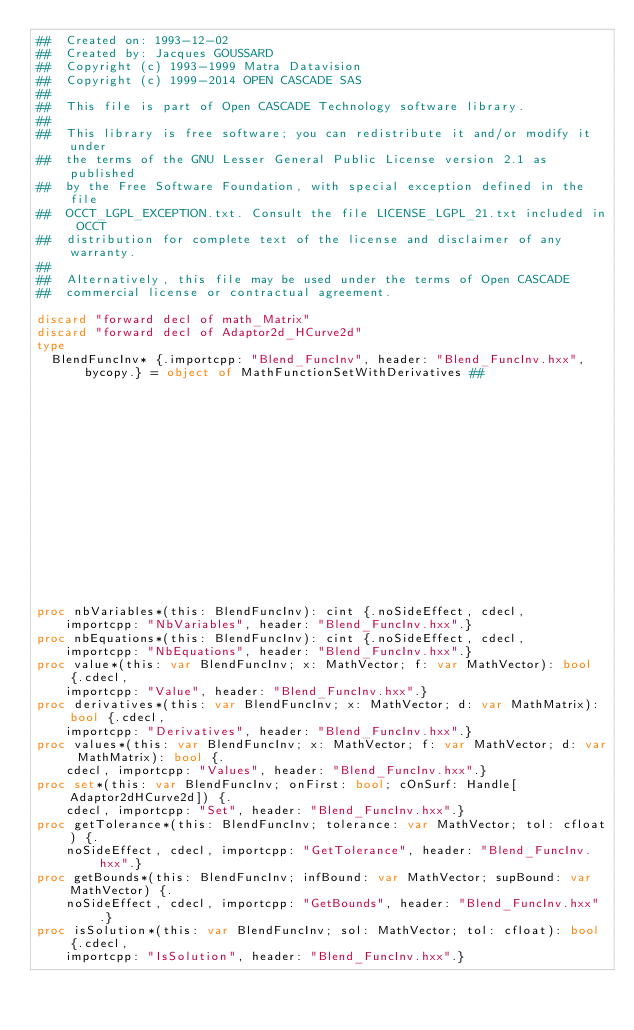Convert code to text. <code><loc_0><loc_0><loc_500><loc_500><_Nim_>##  Created on: 1993-12-02
##  Created by: Jacques GOUSSARD
##  Copyright (c) 1993-1999 Matra Datavision
##  Copyright (c) 1999-2014 OPEN CASCADE SAS
##
##  This file is part of Open CASCADE Technology software library.
##
##  This library is free software; you can redistribute it and/or modify it under
##  the terms of the GNU Lesser General Public License version 2.1 as published
##  by the Free Software Foundation, with special exception defined in the file
##  OCCT_LGPL_EXCEPTION.txt. Consult the file LICENSE_LGPL_21.txt included in OCCT
##  distribution for complete text of the license and disclaimer of any warranty.
##
##  Alternatively, this file may be used under the terms of Open CASCADE
##  commercial license or contractual agreement.

discard "forward decl of math_Matrix"
discard "forward decl of Adaptor2d_HCurve2d"
type
  BlendFuncInv* {.importcpp: "Blend_FuncInv", header: "Blend_FuncInv.hxx", bycopy.} = object of MathFunctionSetWithDerivatives ##
                                                                                                                     ## !
                                                                                                                     ## Returns
                                                                                                                     ## 4.


proc nbVariables*(this: BlendFuncInv): cint {.noSideEffect, cdecl,
    importcpp: "NbVariables", header: "Blend_FuncInv.hxx".}
proc nbEquations*(this: BlendFuncInv): cint {.noSideEffect, cdecl,
    importcpp: "NbEquations", header: "Blend_FuncInv.hxx".}
proc value*(this: var BlendFuncInv; x: MathVector; f: var MathVector): bool {.cdecl,
    importcpp: "Value", header: "Blend_FuncInv.hxx".}
proc derivatives*(this: var BlendFuncInv; x: MathVector; d: var MathMatrix): bool {.cdecl,
    importcpp: "Derivatives", header: "Blend_FuncInv.hxx".}
proc values*(this: var BlendFuncInv; x: MathVector; f: var MathVector; d: var MathMatrix): bool {.
    cdecl, importcpp: "Values", header: "Blend_FuncInv.hxx".}
proc set*(this: var BlendFuncInv; onFirst: bool; cOnSurf: Handle[Adaptor2dHCurve2d]) {.
    cdecl, importcpp: "Set", header: "Blend_FuncInv.hxx".}
proc getTolerance*(this: BlendFuncInv; tolerance: var MathVector; tol: cfloat) {.
    noSideEffect, cdecl, importcpp: "GetTolerance", header: "Blend_FuncInv.hxx".}
proc getBounds*(this: BlendFuncInv; infBound: var MathVector; supBound: var MathVector) {.
    noSideEffect, cdecl, importcpp: "GetBounds", header: "Blend_FuncInv.hxx".}
proc isSolution*(this: var BlendFuncInv; sol: MathVector; tol: cfloat): bool {.cdecl,
    importcpp: "IsSolution", header: "Blend_FuncInv.hxx".}</code> 